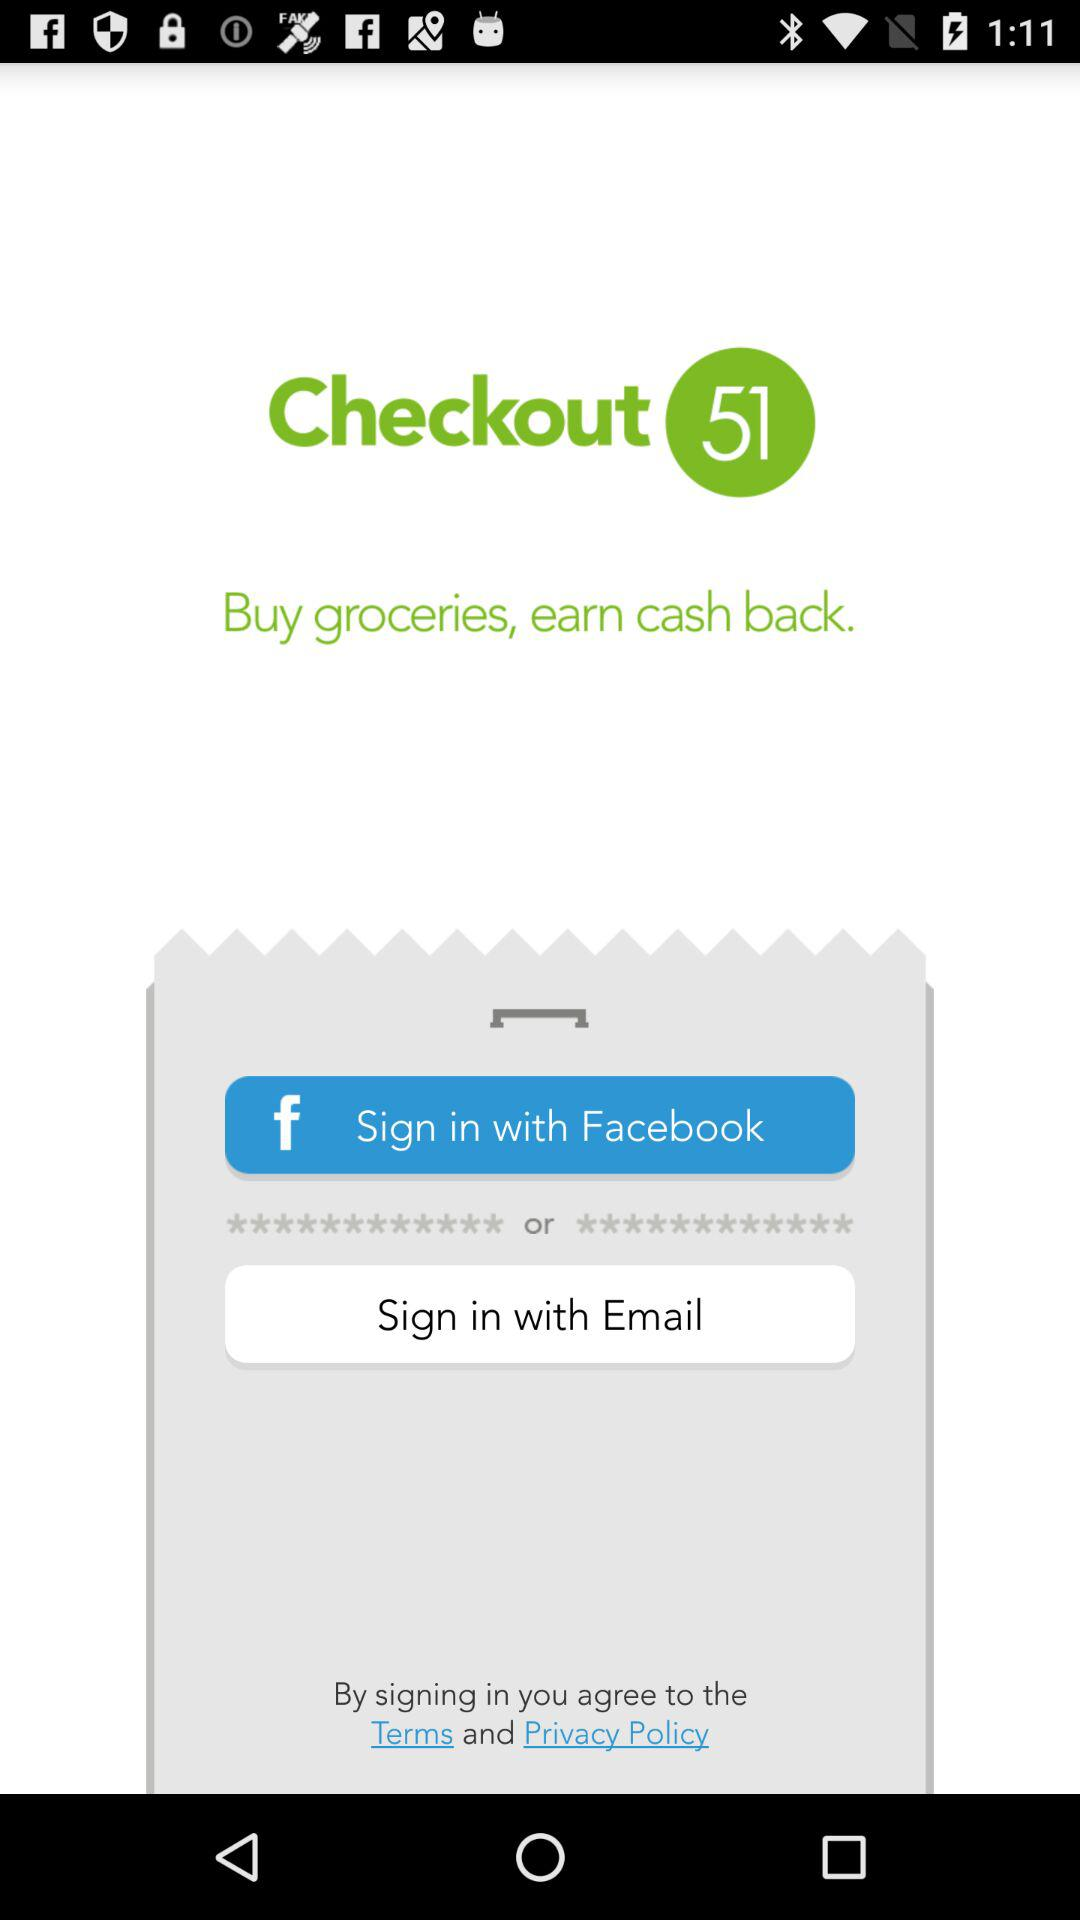What is the application name? The application name "Checkout 51". 